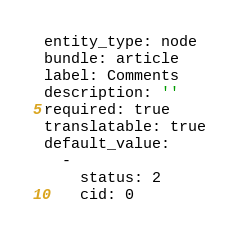Convert code to text. <code><loc_0><loc_0><loc_500><loc_500><_YAML_>entity_type: node
bundle: article
label: Comments
description: ''
required: true
translatable: true
default_value:
  -
    status: 2
    cid: 0</code> 